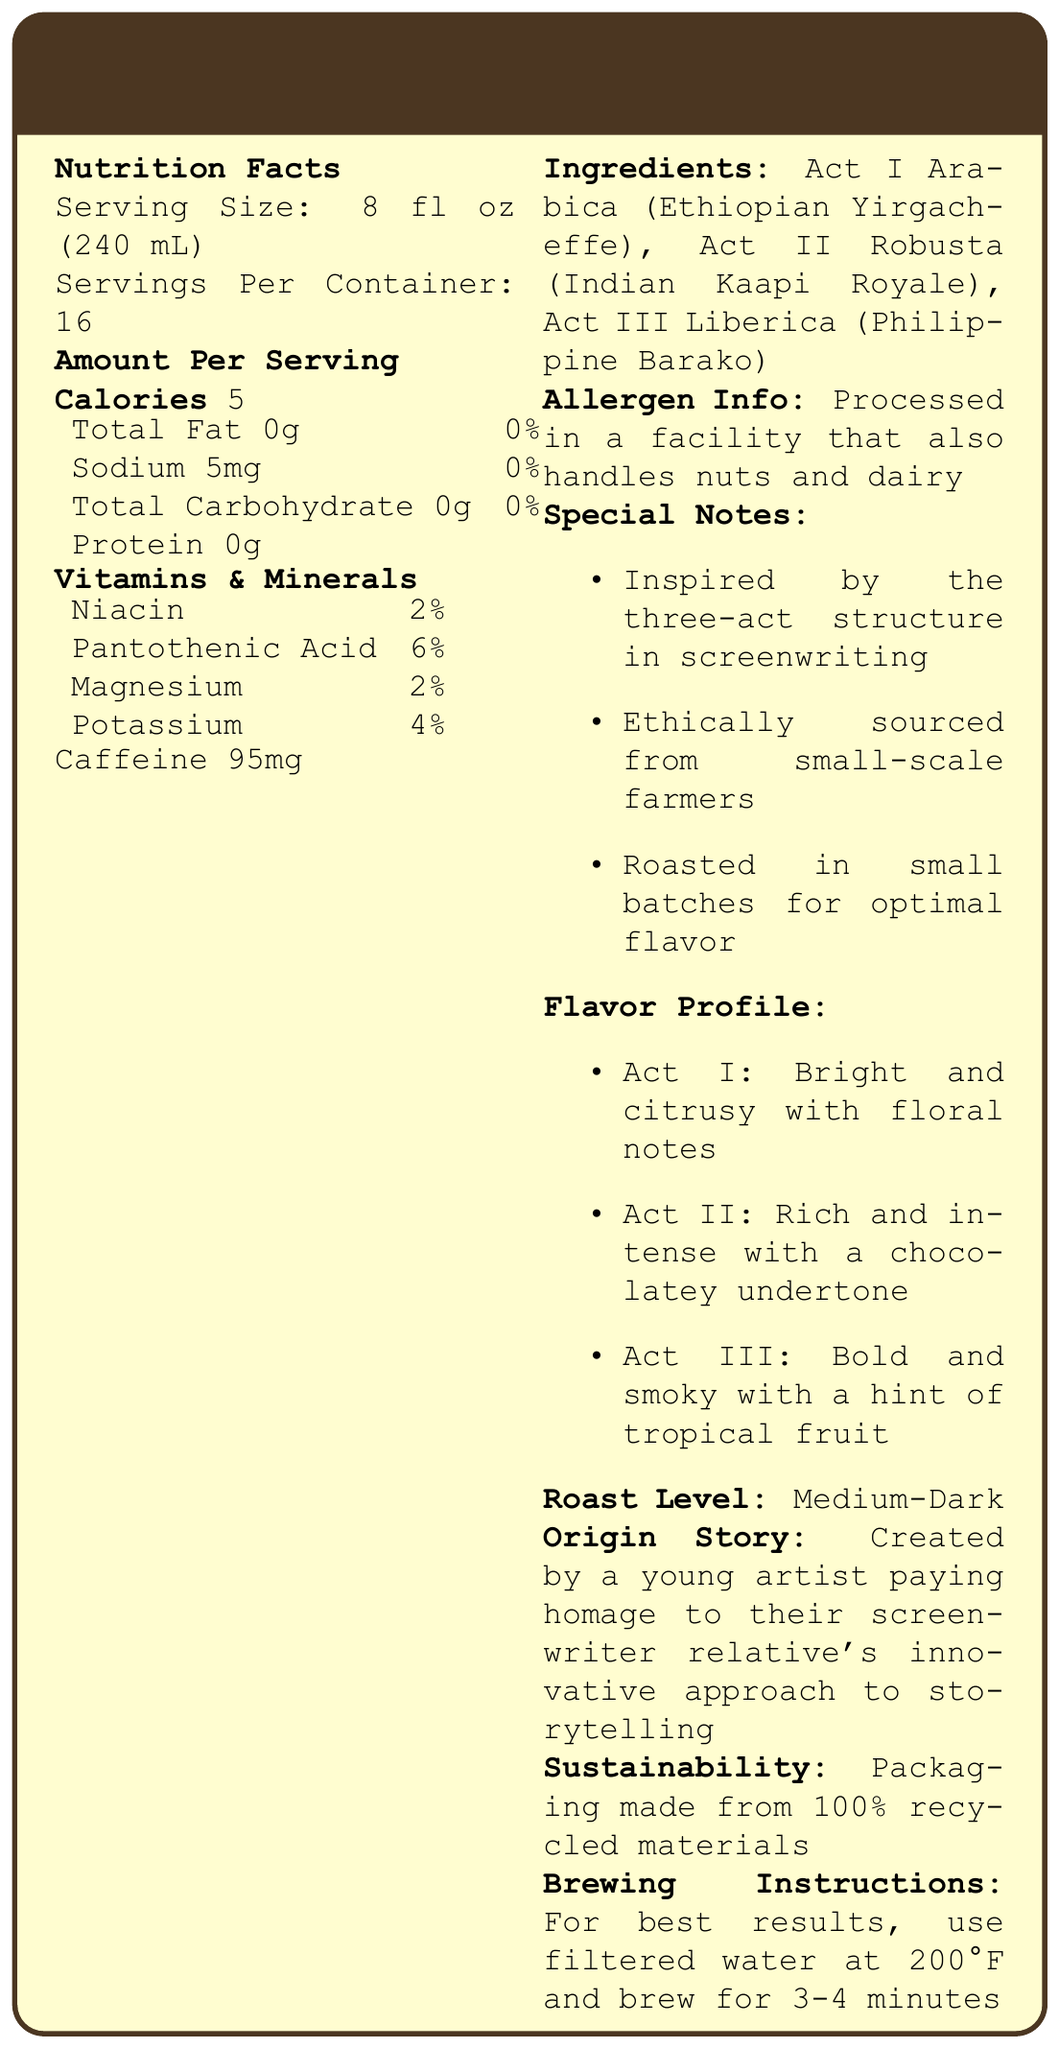what is the serving size? The document states "Serving Size: 8 fl oz (240 mL)" in the Nutrition Facts section.
Answer: 8 fl oz (240 mL) how many servings are in each container? The document specifies "Servings Per Container: 16" in the Nutrition Facts section.
Answer: 16 how many calories are in one serving? The document lists "Calories 5" under the Amount Per Serving section.
Answer: 5 how much sodium is in one serving? The document states "Sodium 5mg" in the nutrition information table.
Answer: 5mg what is the caffeine content per serving? The document mentions "Caffeine 95mg" in the Amount Per Serving section.
Answer: 95mg which of the following vitamins are listed in the document? A. Vitamin A B. Vitamin C C. Niacin D. Vitamin D The document lists "Niacin" under Vitamins & Minerals, but does not mention Vitamin A, Vitamin C, or Vitamin D.
Answer: C. Niacin what allergens are handled in the facility where this product is processed? The document contains the statement "Processed in a facility that also handles nuts and dairy."
Answer: nuts and dairy what are the main ingredients of the blend? The ingredients are listed in the Ingredients section of the document.
Answer: Act I Arabica (Ethiopian Yirgacheffe), Act II Robusta (Indian Kaapi Royale), Act III Liberica (Philippine Barako) which flavor is associated with Act II? A. Bright and citrusy B. Rich and intense C. Bold and smoky The flavor profile section states that Act II has a "Rich and intense with a chocolatey undertone" flavor.
Answer: B. Rich and intense is the packaging made from sustainable materials? The sustainability section notes that the packaging is made from "100% recycled materials."
Answer: Yes what is the roast level of this coffee blend? The document states "Roast Level: Medium-Dark."
Answer: Medium-Dark how long should you brew this coffee for optimal flavor? According to the Brewing Instructions section, the best results are achieved by brewing for 3-4 minutes.
Answer: 3-4 minutes what is the document mainly about? The document outlines various details about the espresso blend, including nutritional information, ingredients, allergen info, flavor profile, special notes, roast level, origin story, sustainability info, and brewing instructions.
Answer: The document provides nutrition, ingredient, and flavor profile information for the Screenplay Brew: Three-Act Espresso Blend. how much potassium is in a serving? The document lists Potassium as 4% under Vitamins & Minerals.
Answer: 4% of the daily value what is the inspiration behind this coffee blend? The Origin Story section explains that the coffee blend was created by a young artist in homage to their screenwriter relative's innovative storytelling.
Answer: Paying homage to the screenwriter relative's innovative approach to storytelling. how much protein is in one serving? The document lists protein in the nutrition information table as "0g".
Answer: 0g how many grams of carbohydrates are in one serving? The document states "Total Carbohydrate 0g" in the nutrition information table.
Answer: 0g what is the main idea behind the flavors in the Screenplay Brew? The document states that the coffee blend is inspired by the three-act structure in screenwriting, with different flavors representing each act.
Answer: The flavors are inspired by different acts in a screenplay, with each act featuring a unique flavor profile. what percentage of daily value of Pantothenic Acid does one serving provide? The Vitamins & Minerals section lists Pantothenic Acid as 6%.
Answer: 6% what are the brewing temperature recommendations for this coffee? The Brewing Instructions section suggests using filtered water at 200°F for best results.
Answer: 200°F what type of water should be used for brewing this coffee for optimal results? The Brewing Instructions recommend using filtered water for optimal results.
Answer: filtered water what is the coffee blend's connection to the artist's family? The Origin Story section explains the blend's connection to the artist's screenwriter relative.
Answer: The coffee blend was created in homage to the screenwriter relative's approach to storytelling. what is the calorie content for the entire container? The document provides the calories per serving and the number of servings per container but does not directly provide the total calorie content for the entire container. Calculation is required.
Answer: Cannot be determined 